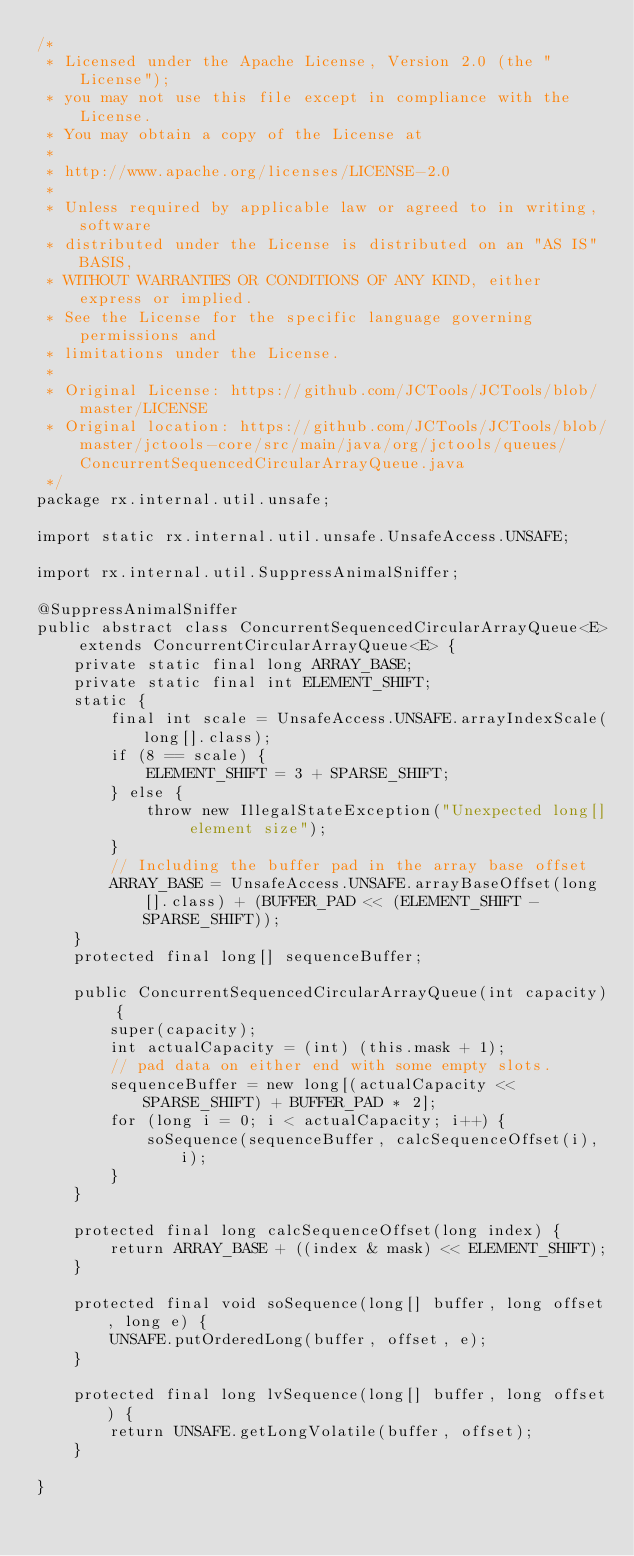<code> <loc_0><loc_0><loc_500><loc_500><_Java_>/*
 * Licensed under the Apache License, Version 2.0 (the "License");
 * you may not use this file except in compliance with the License.
 * You may obtain a copy of the License at
 *
 * http://www.apache.org/licenses/LICENSE-2.0
 *
 * Unless required by applicable law or agreed to in writing, software
 * distributed under the License is distributed on an "AS IS" BASIS,
 * WITHOUT WARRANTIES OR CONDITIONS OF ANY KIND, either express or implied.
 * See the License for the specific language governing permissions and
 * limitations under the License.
 *
 * Original License: https://github.com/JCTools/JCTools/blob/master/LICENSE
 * Original location: https://github.com/JCTools/JCTools/blob/master/jctools-core/src/main/java/org/jctools/queues/ConcurrentSequencedCircularArrayQueue.java
 */
package rx.internal.util.unsafe;

import static rx.internal.util.unsafe.UnsafeAccess.UNSAFE;

import rx.internal.util.SuppressAnimalSniffer;

@SuppressAnimalSniffer
public abstract class ConcurrentSequencedCircularArrayQueue<E> extends ConcurrentCircularArrayQueue<E> {
    private static final long ARRAY_BASE;
    private static final int ELEMENT_SHIFT;
    static {
        final int scale = UnsafeAccess.UNSAFE.arrayIndexScale(long[].class);
        if (8 == scale) {
            ELEMENT_SHIFT = 3 + SPARSE_SHIFT;
        } else {
            throw new IllegalStateException("Unexpected long[] element size");
        }
        // Including the buffer pad in the array base offset
        ARRAY_BASE = UnsafeAccess.UNSAFE.arrayBaseOffset(long[].class) + (BUFFER_PAD << (ELEMENT_SHIFT - SPARSE_SHIFT));
    }
    protected final long[] sequenceBuffer;

    public ConcurrentSequencedCircularArrayQueue(int capacity) {
        super(capacity);
        int actualCapacity = (int) (this.mask + 1);
        // pad data on either end with some empty slots.
        sequenceBuffer = new long[(actualCapacity << SPARSE_SHIFT) + BUFFER_PAD * 2];
        for (long i = 0; i < actualCapacity; i++) {
            soSequence(sequenceBuffer, calcSequenceOffset(i), i);
        }
    }

    protected final long calcSequenceOffset(long index) {
        return ARRAY_BASE + ((index & mask) << ELEMENT_SHIFT);
    }

    protected final void soSequence(long[] buffer, long offset, long e) {
        UNSAFE.putOrderedLong(buffer, offset, e);
    }

    protected final long lvSequence(long[] buffer, long offset) {
        return UNSAFE.getLongVolatile(buffer, offset);
    }

}
</code> 